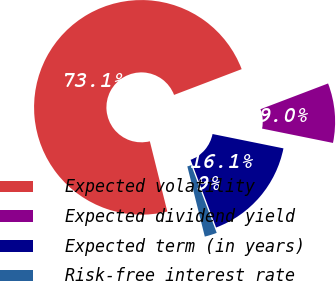Convert chart to OTSL. <chart><loc_0><loc_0><loc_500><loc_500><pie_chart><fcel>Expected volatility<fcel>Expected dividend yield<fcel>Expected term (in years)<fcel>Risk-free interest rate<nl><fcel>73.09%<fcel>8.97%<fcel>16.09%<fcel>1.85%<nl></chart> 